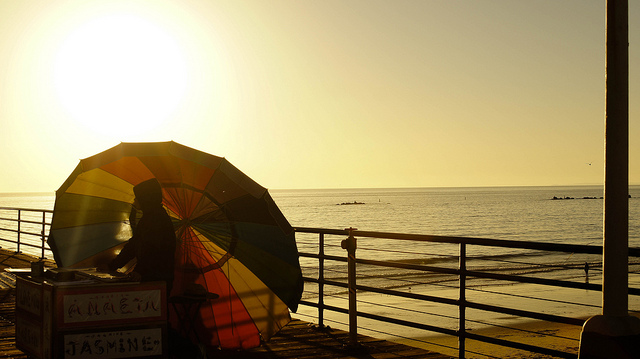What is the man holding? The man is holding a large, multi-colored beach umbrella. This type of umbrella is commonly used to provide shade and protection from the sun while relaxing by the sea or on a beach. 